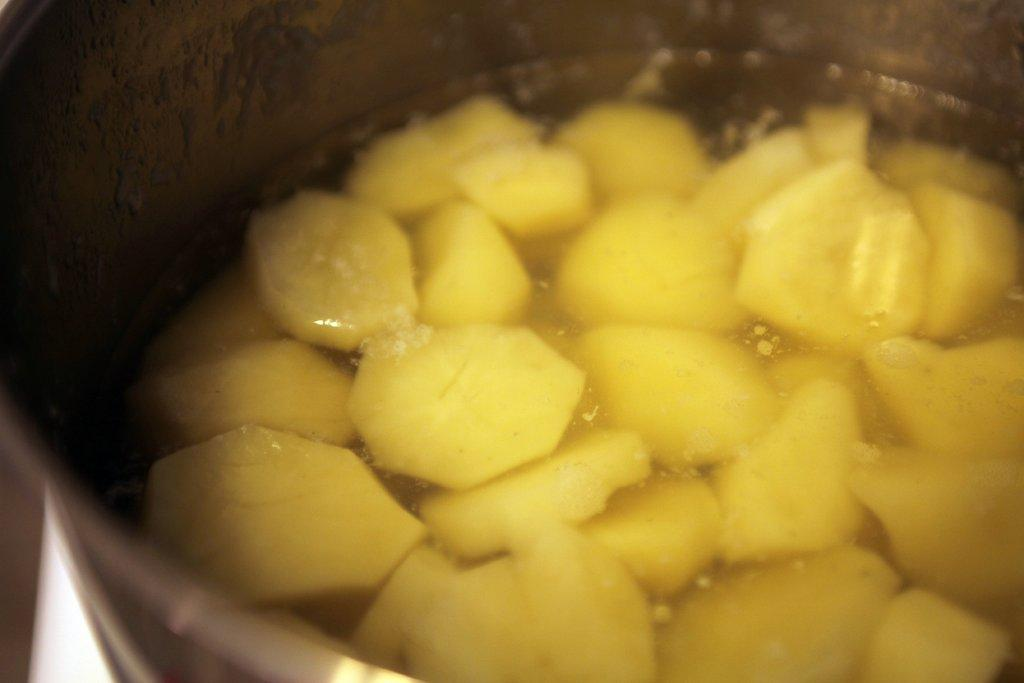What type of food item can be seen in the image? There are slices of a food item in the image. How are the food item slices arranged or presented? The food item slices are in water. What is the water contained within? The water is contained within a cup. What type of honey can be seen dripping from the wing of the ornament in the image? There is no honey, wing, or ornament present in the image. 